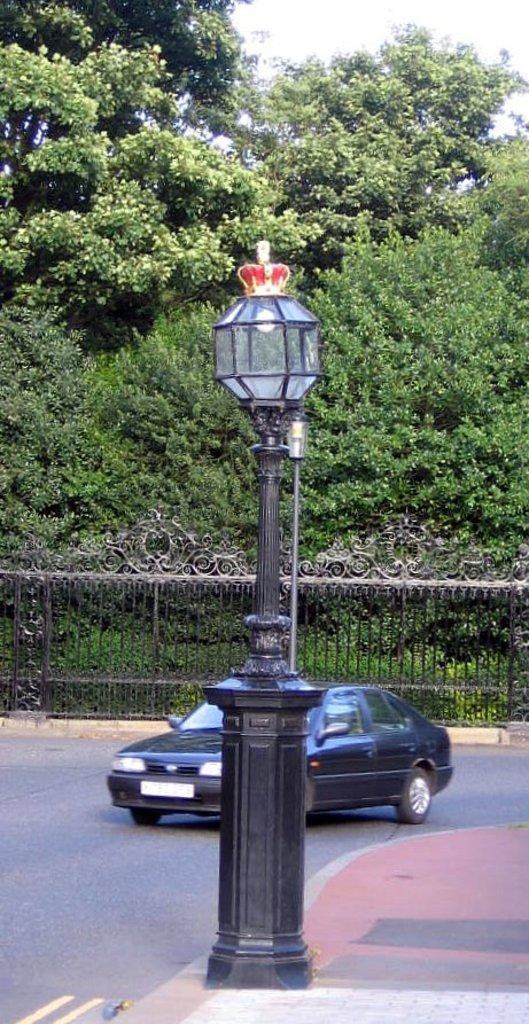How would you summarize this image in a sentence or two? In this image I can see road and on it I can see a black colour car. I can also see few poles, few lights, iron gate and number of trees. 